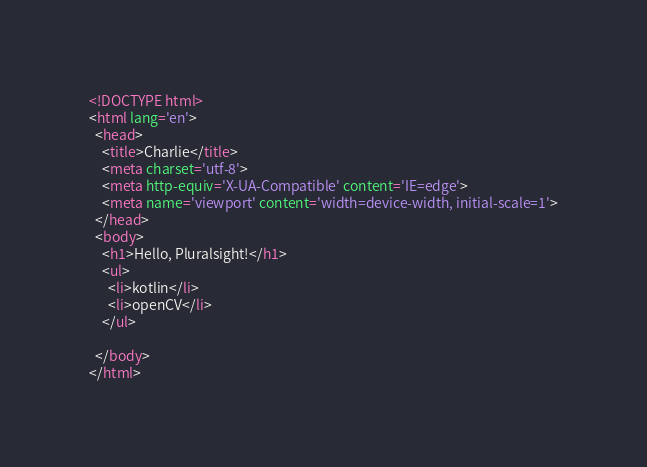<code> <loc_0><loc_0><loc_500><loc_500><_HTML_><!DOCTYPE html>
<html lang='en'>
  <head>
    <title>Charlie</title>
    <meta charset='utf-8'>
    <meta http-equiv='X-UA-Compatible' content='IE=edge'>
    <meta name='viewport' content='width=device-width, initial-scale=1'>
  </head>
  <body>
    <h1>Hello, Pluralsight!</h1>
    <ul>
      <li>kotlin</li>
      <li>openCV</li>
    </ul>

  </body> 
</html>
</code> 